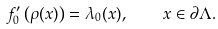<formula> <loc_0><loc_0><loc_500><loc_500>f _ { 0 } ^ { \prime } \left ( \rho ( x ) \right ) = \lambda _ { 0 } ( x ) , \quad x \in \partial \Lambda .</formula> 